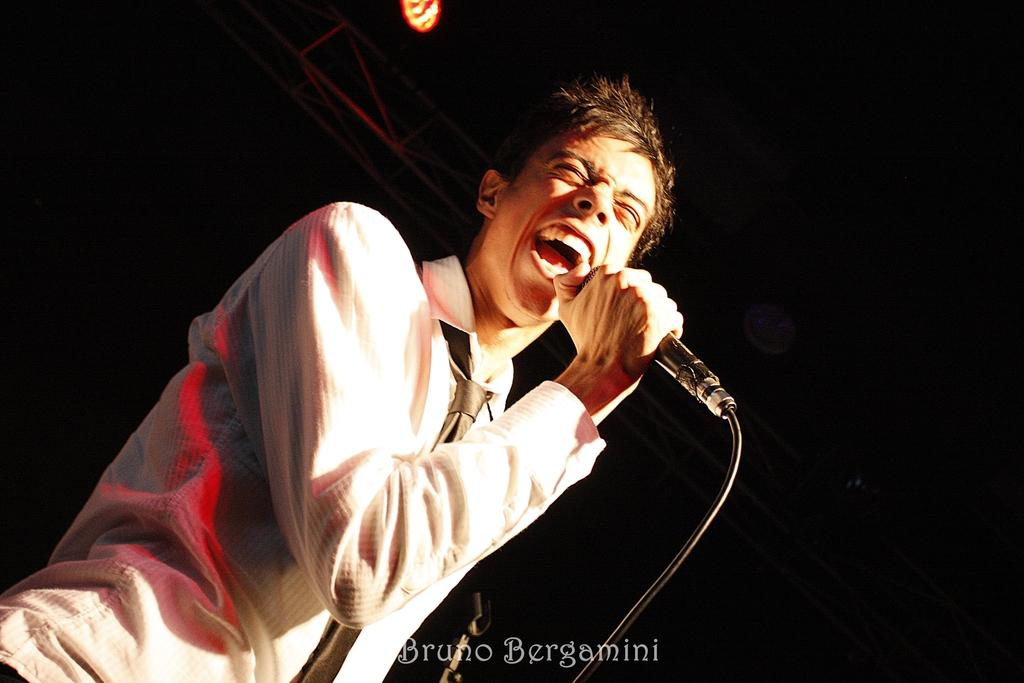What is the man in the image doing? The man is singing in the image. What is the man holding while singing? The man is holding a microphone. What can be observed about the background of the image? The background of the image is dark. Is there any additional information or branding present in the image? Yes, there is a watermark at the bottom of the image. How does the man pump water while singing in the image? There is no pump or water present in the image; the man is simply singing while holding a microphone. 